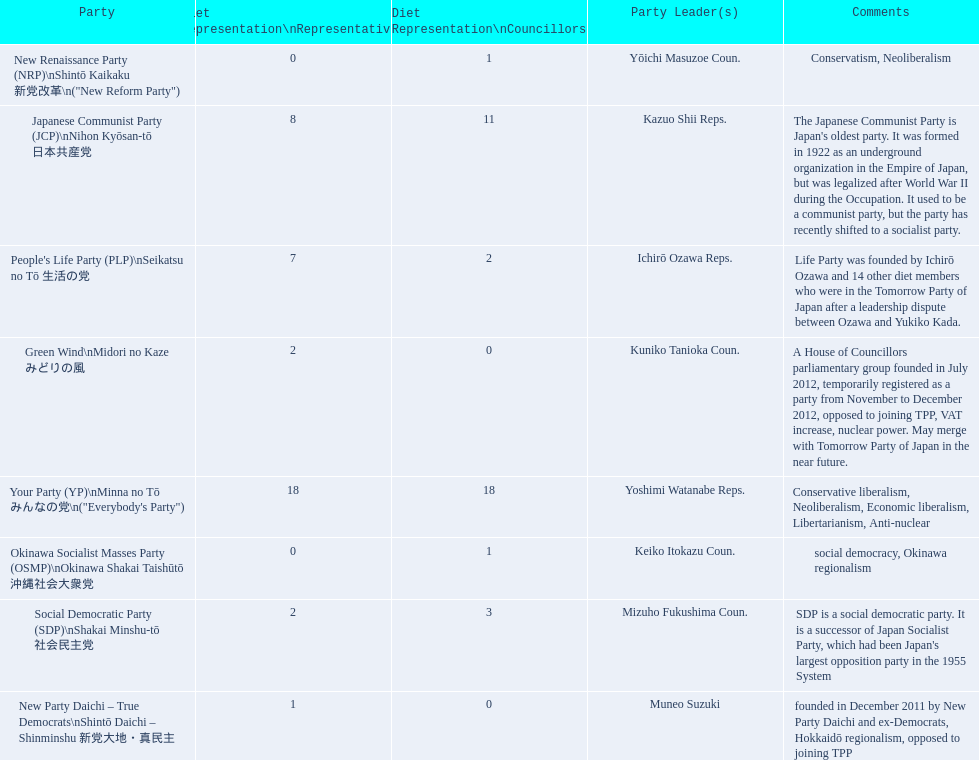What party is listed previous to the new renaissance party? New Party Daichi - True Democrats. 